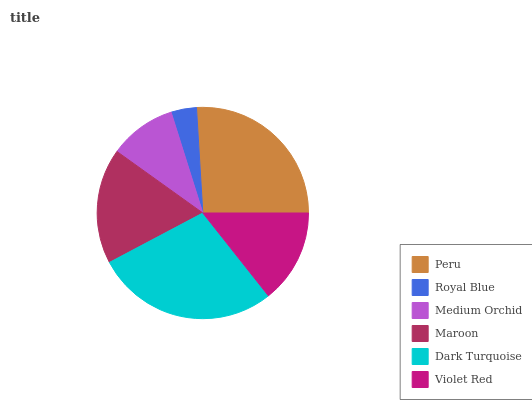Is Royal Blue the minimum?
Answer yes or no. Yes. Is Dark Turquoise the maximum?
Answer yes or no. Yes. Is Medium Orchid the minimum?
Answer yes or no. No. Is Medium Orchid the maximum?
Answer yes or no. No. Is Medium Orchid greater than Royal Blue?
Answer yes or no. Yes. Is Royal Blue less than Medium Orchid?
Answer yes or no. Yes. Is Royal Blue greater than Medium Orchid?
Answer yes or no. No. Is Medium Orchid less than Royal Blue?
Answer yes or no. No. Is Maroon the high median?
Answer yes or no. Yes. Is Violet Red the low median?
Answer yes or no. Yes. Is Dark Turquoise the high median?
Answer yes or no. No. Is Medium Orchid the low median?
Answer yes or no. No. 